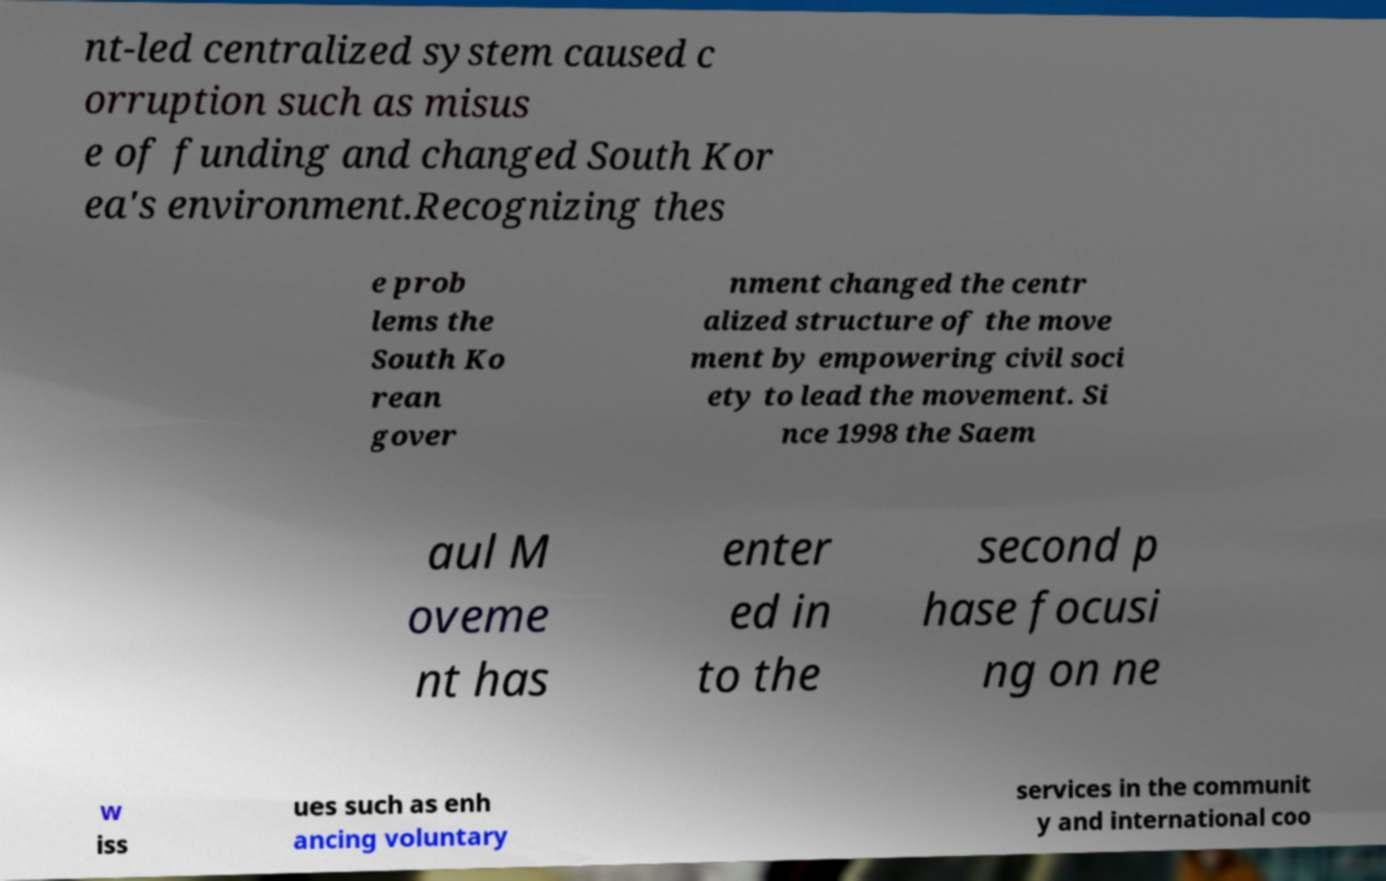Please identify and transcribe the text found in this image. nt-led centralized system caused c orruption such as misus e of funding and changed South Kor ea's environment.Recognizing thes e prob lems the South Ko rean gover nment changed the centr alized structure of the move ment by empowering civil soci ety to lead the movement. Si nce 1998 the Saem aul M oveme nt has enter ed in to the second p hase focusi ng on ne w iss ues such as enh ancing voluntary services in the communit y and international coo 